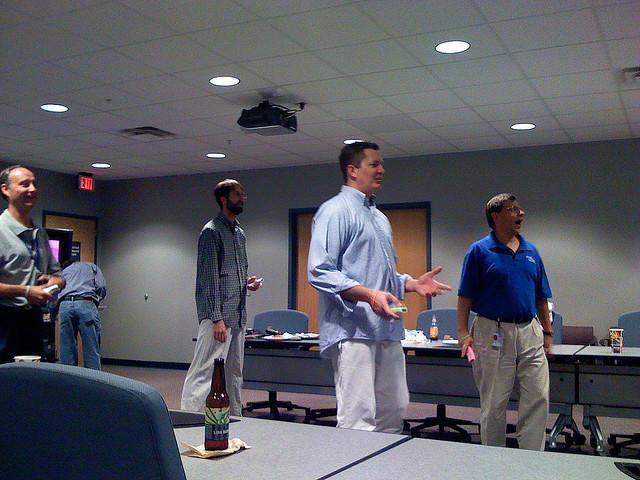How many people can you see?
Give a very brief answer. 5. 